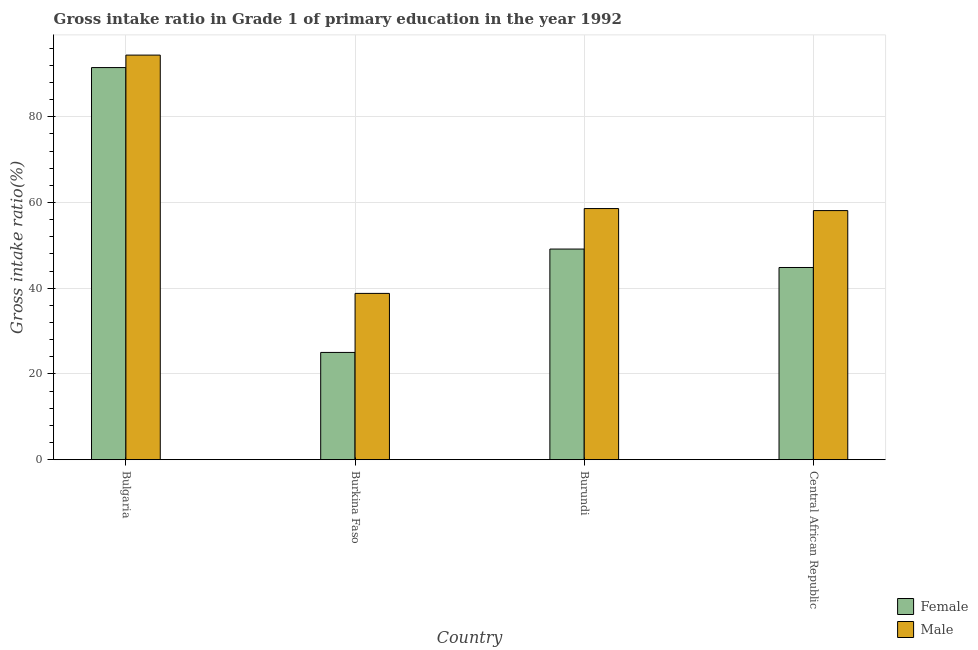How many different coloured bars are there?
Ensure brevity in your answer.  2. How many groups of bars are there?
Offer a very short reply. 4. Are the number of bars per tick equal to the number of legend labels?
Keep it short and to the point. Yes. Are the number of bars on each tick of the X-axis equal?
Your answer should be very brief. Yes. How many bars are there on the 2nd tick from the left?
Offer a terse response. 2. How many bars are there on the 4th tick from the right?
Keep it short and to the point. 2. What is the label of the 3rd group of bars from the left?
Offer a very short reply. Burundi. What is the gross intake ratio(female) in Bulgaria?
Ensure brevity in your answer.  91.49. Across all countries, what is the maximum gross intake ratio(female)?
Ensure brevity in your answer.  91.49. Across all countries, what is the minimum gross intake ratio(female)?
Your answer should be very brief. 25.03. In which country was the gross intake ratio(female) maximum?
Provide a succinct answer. Bulgaria. In which country was the gross intake ratio(female) minimum?
Provide a succinct answer. Burkina Faso. What is the total gross intake ratio(female) in the graph?
Offer a terse response. 210.51. What is the difference between the gross intake ratio(female) in Bulgaria and that in Burkina Faso?
Offer a terse response. 66.46. What is the difference between the gross intake ratio(male) in Burkina Faso and the gross intake ratio(female) in Bulgaria?
Give a very brief answer. -52.69. What is the average gross intake ratio(female) per country?
Your answer should be compact. 52.63. What is the difference between the gross intake ratio(male) and gross intake ratio(female) in Central African Republic?
Keep it short and to the point. 13.27. In how many countries, is the gross intake ratio(female) greater than 56 %?
Offer a very short reply. 1. What is the ratio of the gross intake ratio(male) in Burundi to that in Central African Republic?
Provide a short and direct response. 1.01. What is the difference between the highest and the second highest gross intake ratio(female)?
Offer a terse response. 42.34. What is the difference between the highest and the lowest gross intake ratio(female)?
Your answer should be very brief. 66.46. In how many countries, is the gross intake ratio(male) greater than the average gross intake ratio(male) taken over all countries?
Your answer should be very brief. 1. Is the sum of the gross intake ratio(male) in Bulgaria and Burkina Faso greater than the maximum gross intake ratio(female) across all countries?
Offer a very short reply. Yes. What does the 1st bar from the right in Central African Republic represents?
Provide a short and direct response. Male. How many bars are there?
Give a very brief answer. 8. How many countries are there in the graph?
Provide a short and direct response. 4. What is the difference between two consecutive major ticks on the Y-axis?
Your answer should be compact. 20. Are the values on the major ticks of Y-axis written in scientific E-notation?
Make the answer very short. No. Does the graph contain any zero values?
Keep it short and to the point. No. How many legend labels are there?
Give a very brief answer. 2. How are the legend labels stacked?
Provide a short and direct response. Vertical. What is the title of the graph?
Keep it short and to the point. Gross intake ratio in Grade 1 of primary education in the year 1992. Does "Exports of goods" appear as one of the legend labels in the graph?
Your answer should be very brief. No. What is the label or title of the Y-axis?
Your answer should be compact. Gross intake ratio(%). What is the Gross intake ratio(%) in Female in Bulgaria?
Your answer should be compact. 91.49. What is the Gross intake ratio(%) in Male in Bulgaria?
Offer a terse response. 94.4. What is the Gross intake ratio(%) of Female in Burkina Faso?
Offer a terse response. 25.03. What is the Gross intake ratio(%) of Male in Burkina Faso?
Offer a terse response. 38.8. What is the Gross intake ratio(%) in Female in Burundi?
Provide a short and direct response. 49.15. What is the Gross intake ratio(%) of Male in Burundi?
Keep it short and to the point. 58.59. What is the Gross intake ratio(%) in Female in Central African Republic?
Provide a succinct answer. 44.85. What is the Gross intake ratio(%) of Male in Central African Republic?
Give a very brief answer. 58.12. Across all countries, what is the maximum Gross intake ratio(%) of Female?
Provide a succinct answer. 91.49. Across all countries, what is the maximum Gross intake ratio(%) of Male?
Offer a terse response. 94.4. Across all countries, what is the minimum Gross intake ratio(%) of Female?
Your response must be concise. 25.03. Across all countries, what is the minimum Gross intake ratio(%) in Male?
Offer a very short reply. 38.8. What is the total Gross intake ratio(%) of Female in the graph?
Keep it short and to the point. 210.51. What is the total Gross intake ratio(%) of Male in the graph?
Your response must be concise. 249.92. What is the difference between the Gross intake ratio(%) of Female in Bulgaria and that in Burkina Faso?
Provide a short and direct response. 66.46. What is the difference between the Gross intake ratio(%) in Male in Bulgaria and that in Burkina Faso?
Make the answer very short. 55.6. What is the difference between the Gross intake ratio(%) of Female in Bulgaria and that in Burundi?
Your answer should be very brief. 42.34. What is the difference between the Gross intake ratio(%) of Male in Bulgaria and that in Burundi?
Offer a terse response. 35.8. What is the difference between the Gross intake ratio(%) of Female in Bulgaria and that in Central African Republic?
Your answer should be very brief. 46.64. What is the difference between the Gross intake ratio(%) in Male in Bulgaria and that in Central African Republic?
Provide a succinct answer. 36.28. What is the difference between the Gross intake ratio(%) in Female in Burkina Faso and that in Burundi?
Give a very brief answer. -24.12. What is the difference between the Gross intake ratio(%) of Male in Burkina Faso and that in Burundi?
Your response must be concise. -19.79. What is the difference between the Gross intake ratio(%) in Female in Burkina Faso and that in Central African Republic?
Keep it short and to the point. -19.82. What is the difference between the Gross intake ratio(%) of Male in Burkina Faso and that in Central African Republic?
Ensure brevity in your answer.  -19.32. What is the difference between the Gross intake ratio(%) in Female in Burundi and that in Central African Republic?
Offer a terse response. 4.3. What is the difference between the Gross intake ratio(%) in Male in Burundi and that in Central African Republic?
Offer a very short reply. 0.47. What is the difference between the Gross intake ratio(%) of Female in Bulgaria and the Gross intake ratio(%) of Male in Burkina Faso?
Ensure brevity in your answer.  52.69. What is the difference between the Gross intake ratio(%) of Female in Bulgaria and the Gross intake ratio(%) of Male in Burundi?
Give a very brief answer. 32.89. What is the difference between the Gross intake ratio(%) in Female in Bulgaria and the Gross intake ratio(%) in Male in Central African Republic?
Give a very brief answer. 33.37. What is the difference between the Gross intake ratio(%) in Female in Burkina Faso and the Gross intake ratio(%) in Male in Burundi?
Your response must be concise. -33.57. What is the difference between the Gross intake ratio(%) in Female in Burkina Faso and the Gross intake ratio(%) in Male in Central African Republic?
Provide a short and direct response. -33.09. What is the difference between the Gross intake ratio(%) in Female in Burundi and the Gross intake ratio(%) in Male in Central African Republic?
Your answer should be compact. -8.97. What is the average Gross intake ratio(%) in Female per country?
Your answer should be compact. 52.63. What is the average Gross intake ratio(%) of Male per country?
Keep it short and to the point. 62.48. What is the difference between the Gross intake ratio(%) of Female and Gross intake ratio(%) of Male in Bulgaria?
Provide a succinct answer. -2.91. What is the difference between the Gross intake ratio(%) of Female and Gross intake ratio(%) of Male in Burkina Faso?
Offer a very short reply. -13.77. What is the difference between the Gross intake ratio(%) in Female and Gross intake ratio(%) in Male in Burundi?
Provide a succinct answer. -9.45. What is the difference between the Gross intake ratio(%) of Female and Gross intake ratio(%) of Male in Central African Republic?
Offer a very short reply. -13.27. What is the ratio of the Gross intake ratio(%) in Female in Bulgaria to that in Burkina Faso?
Offer a terse response. 3.66. What is the ratio of the Gross intake ratio(%) in Male in Bulgaria to that in Burkina Faso?
Keep it short and to the point. 2.43. What is the ratio of the Gross intake ratio(%) of Female in Bulgaria to that in Burundi?
Your answer should be very brief. 1.86. What is the ratio of the Gross intake ratio(%) in Male in Bulgaria to that in Burundi?
Provide a succinct answer. 1.61. What is the ratio of the Gross intake ratio(%) in Female in Bulgaria to that in Central African Republic?
Provide a succinct answer. 2.04. What is the ratio of the Gross intake ratio(%) of Male in Bulgaria to that in Central African Republic?
Ensure brevity in your answer.  1.62. What is the ratio of the Gross intake ratio(%) of Female in Burkina Faso to that in Burundi?
Your answer should be compact. 0.51. What is the ratio of the Gross intake ratio(%) in Male in Burkina Faso to that in Burundi?
Make the answer very short. 0.66. What is the ratio of the Gross intake ratio(%) in Female in Burkina Faso to that in Central African Republic?
Offer a terse response. 0.56. What is the ratio of the Gross intake ratio(%) of Male in Burkina Faso to that in Central African Republic?
Your answer should be compact. 0.67. What is the ratio of the Gross intake ratio(%) in Female in Burundi to that in Central African Republic?
Provide a succinct answer. 1.1. What is the difference between the highest and the second highest Gross intake ratio(%) in Female?
Offer a very short reply. 42.34. What is the difference between the highest and the second highest Gross intake ratio(%) in Male?
Your answer should be very brief. 35.8. What is the difference between the highest and the lowest Gross intake ratio(%) of Female?
Your answer should be compact. 66.46. What is the difference between the highest and the lowest Gross intake ratio(%) in Male?
Provide a succinct answer. 55.6. 